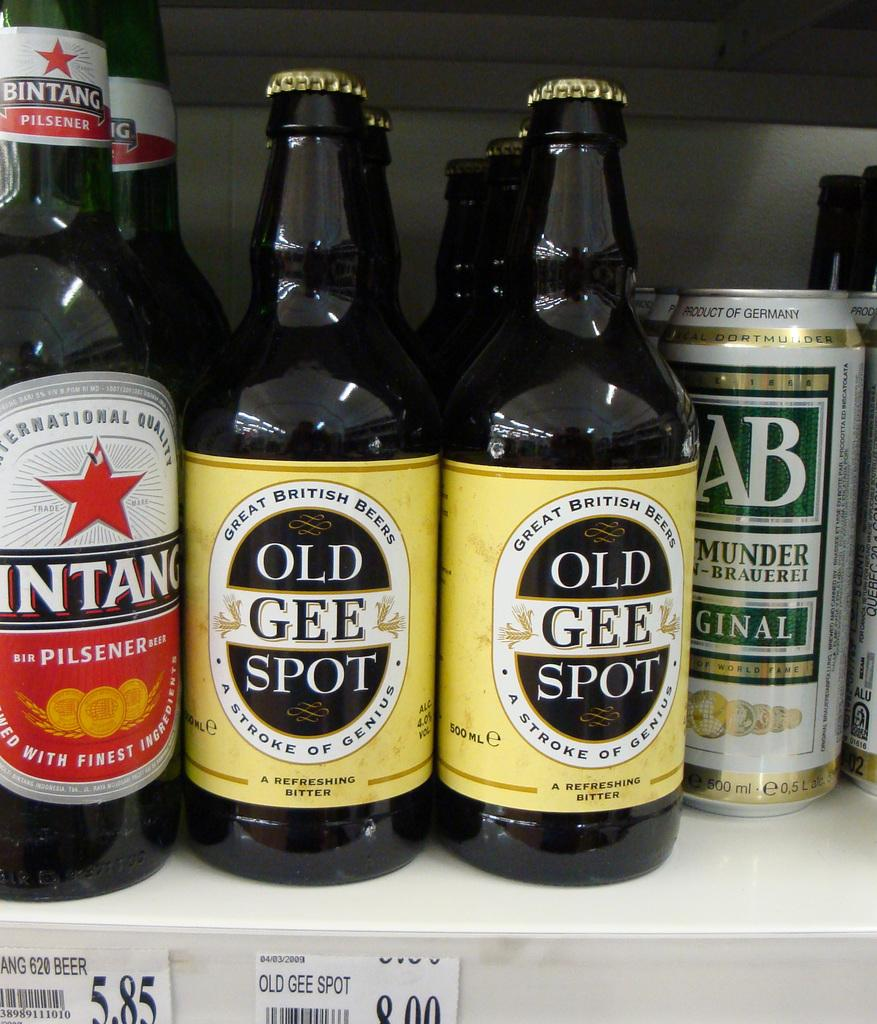<image>
Share a concise interpretation of the image provided. The unusually labelled beer in the middle is called Old Gee Spot. 